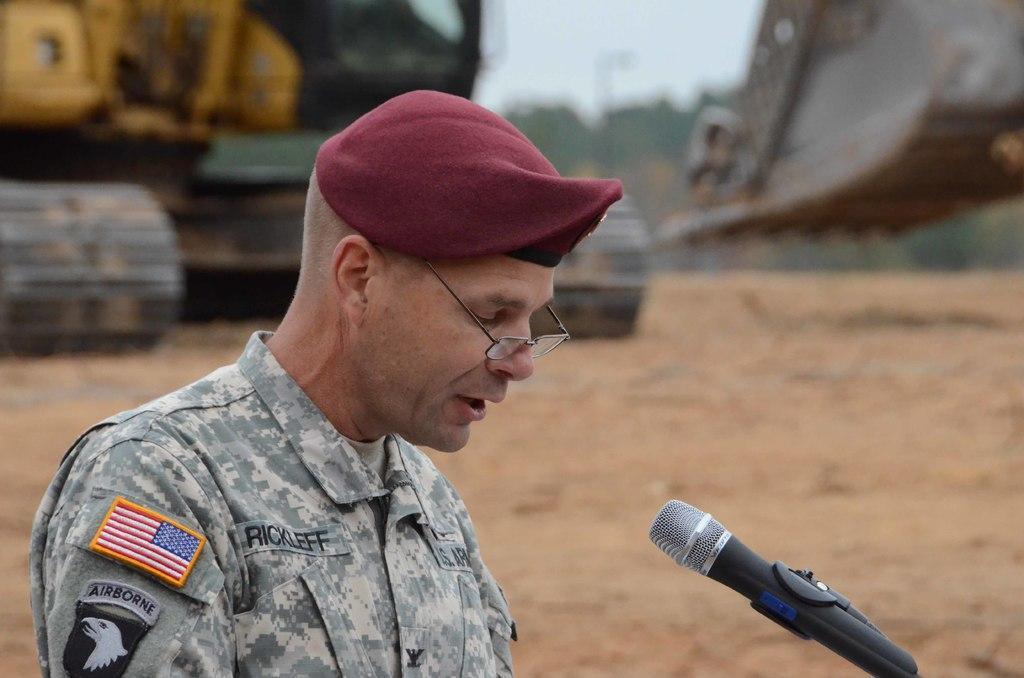In one or two sentences, can you explain what this image depicts? In this image we can see a person with uniform and a mic in front of the person and in the background there is a crane on the ground. 